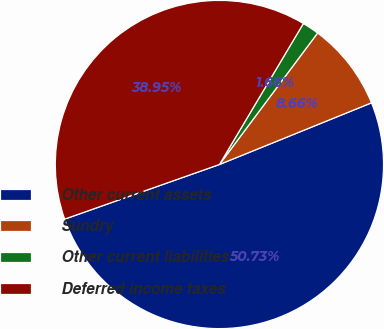Convert chart to OTSL. <chart><loc_0><loc_0><loc_500><loc_500><pie_chart><fcel>Other current assets<fcel>Sundry<fcel>Other current liabilities<fcel>Deferred income taxes<nl><fcel>50.74%<fcel>8.66%<fcel>1.66%<fcel>38.95%<nl></chart> 